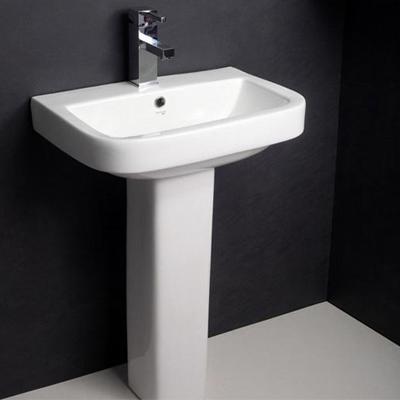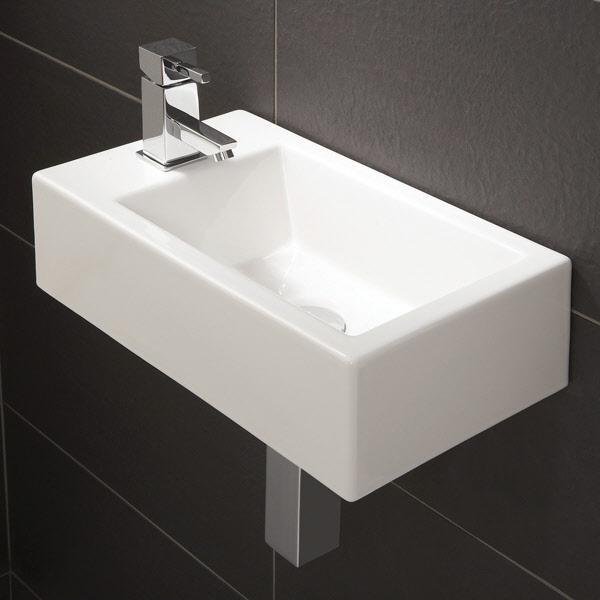The first image is the image on the left, the second image is the image on the right. Given the left and right images, does the statement "At least one sink is sitting on a counter." hold true? Answer yes or no. No. 